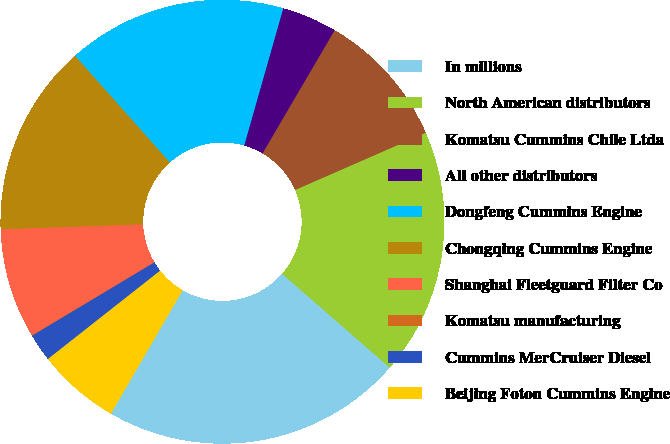Convert chart. <chart><loc_0><loc_0><loc_500><loc_500><pie_chart><fcel>In millions<fcel>North American distributors<fcel>Komatsu Cummins Chile Ltda<fcel>All other distributors<fcel>Dongfeng Cummins Engine<fcel>Chongqing Cummins Engine<fcel>Shanghai Fleetguard Filter Co<fcel>Komatsu manufacturing<fcel>Cummins MerCruiser Diesel<fcel>Beijing Foton Cummins Engine<nl><fcel>21.96%<fcel>17.98%<fcel>10.0%<fcel>4.02%<fcel>15.98%<fcel>13.99%<fcel>8.01%<fcel>0.03%<fcel>2.02%<fcel>6.01%<nl></chart> 